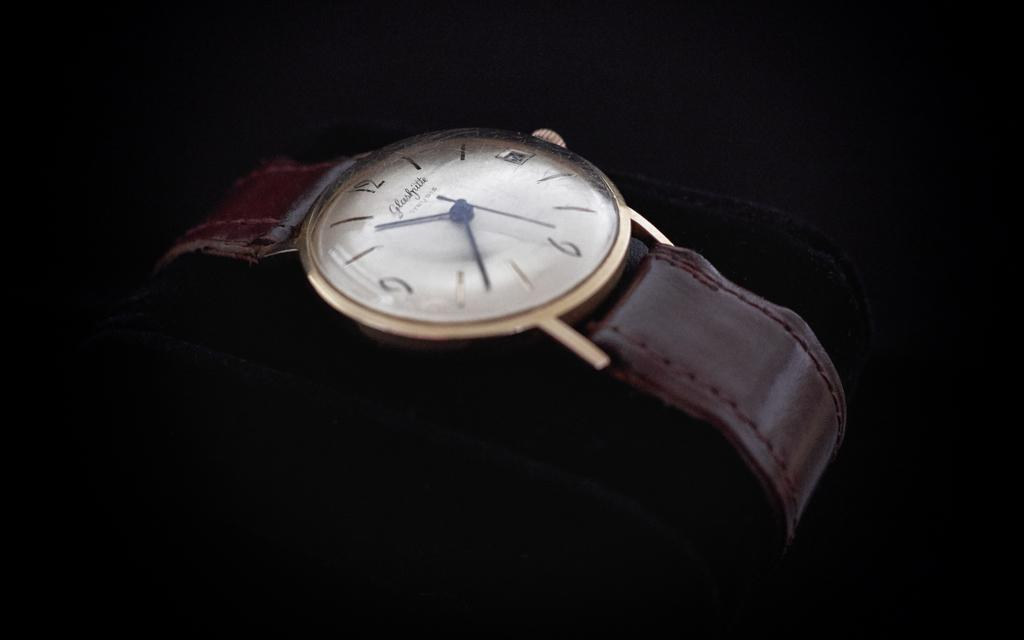<image>
Summarize the visual content of the image. a watch with 1 thru 12 on the front 